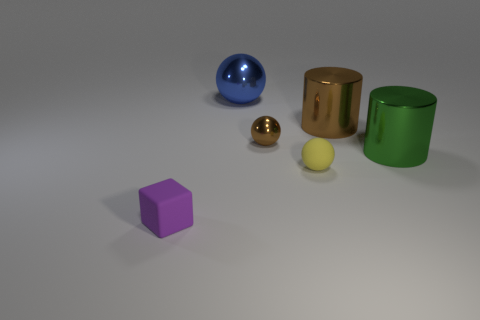How many things are metal objects that are left of the green cylinder or yellow spheres?
Provide a succinct answer. 4. Are there the same number of brown things that are in front of the brown metal ball and large green rubber cylinders?
Provide a succinct answer. Yes. Is the green shiny cylinder the same size as the purple rubber object?
Keep it short and to the point. No. What is the color of the metallic ball that is the same size as the green metallic cylinder?
Make the answer very short. Blue. Is the size of the blue metal sphere the same as the brown metallic object on the right side of the yellow thing?
Give a very brief answer. Yes. How many tiny shiny balls are the same color as the tiny matte cube?
Offer a terse response. 0. What number of things are either large green things or brown things on the right side of the small yellow sphere?
Give a very brief answer. 2. There is a rubber object left of the brown ball; does it have the same size as the brown metallic thing in front of the large brown metal thing?
Offer a terse response. Yes. Are there any big yellow blocks made of the same material as the large brown cylinder?
Your response must be concise. No. What is the shape of the tiny purple rubber thing?
Provide a short and direct response. Cube. 